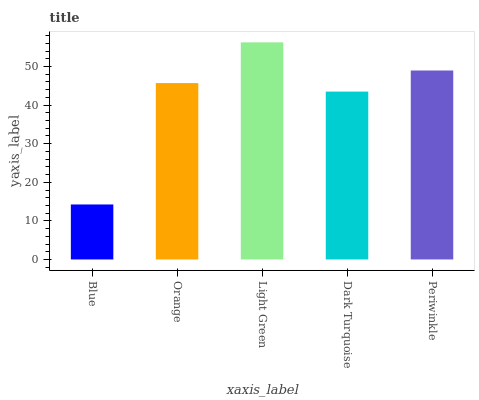Is Blue the minimum?
Answer yes or no. Yes. Is Light Green the maximum?
Answer yes or no. Yes. Is Orange the minimum?
Answer yes or no. No. Is Orange the maximum?
Answer yes or no. No. Is Orange greater than Blue?
Answer yes or no. Yes. Is Blue less than Orange?
Answer yes or no. Yes. Is Blue greater than Orange?
Answer yes or no. No. Is Orange less than Blue?
Answer yes or no. No. Is Orange the high median?
Answer yes or no. Yes. Is Orange the low median?
Answer yes or no. Yes. Is Periwinkle the high median?
Answer yes or no. No. Is Blue the low median?
Answer yes or no. No. 